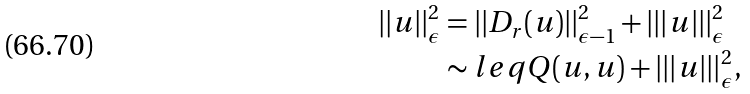<formula> <loc_0><loc_0><loc_500><loc_500>| | u | | ^ { 2 } _ { \epsilon } & = | | D _ { r } ( u ) | | ^ { 2 } _ { \epsilon - 1 } + | | | u | | | ^ { 2 } _ { \epsilon } \\ & \sim l e q Q ( u , u ) + | | | u | | | ^ { 2 } _ { \epsilon } ,</formula> 